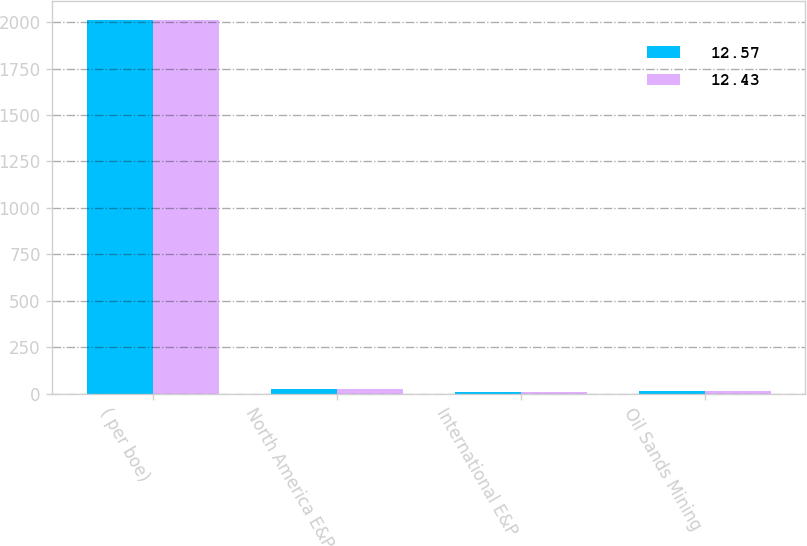<chart> <loc_0><loc_0><loc_500><loc_500><stacked_bar_chart><ecel><fcel>( per boe)<fcel>North America E&P<fcel>International E&P<fcel>Oil Sands Mining<nl><fcel>12.57<fcel>2012<fcel>23.45<fcel>8.08<fcel>12.57<nl><fcel>12.43<fcel>2011<fcel>25.15<fcel>9.7<fcel>12.43<nl></chart> 